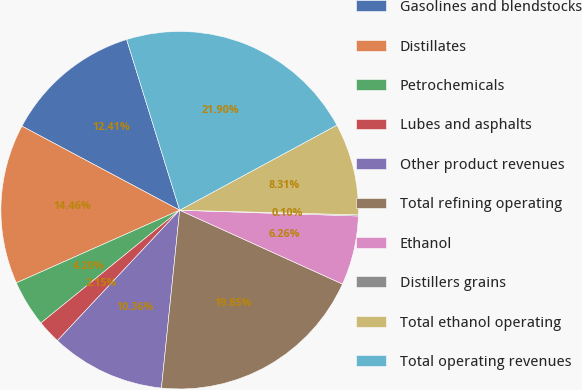Convert chart. <chart><loc_0><loc_0><loc_500><loc_500><pie_chart><fcel>Gasolines and blendstocks<fcel>Distillates<fcel>Petrochemicals<fcel>Lubes and asphalts<fcel>Other product revenues<fcel>Total refining operating<fcel>Ethanol<fcel>Distillers grains<fcel>Total ethanol operating<fcel>Total operating revenues<nl><fcel>12.41%<fcel>14.46%<fcel>4.2%<fcel>2.15%<fcel>10.36%<fcel>19.85%<fcel>6.26%<fcel>0.1%<fcel>8.31%<fcel>21.9%<nl></chart> 